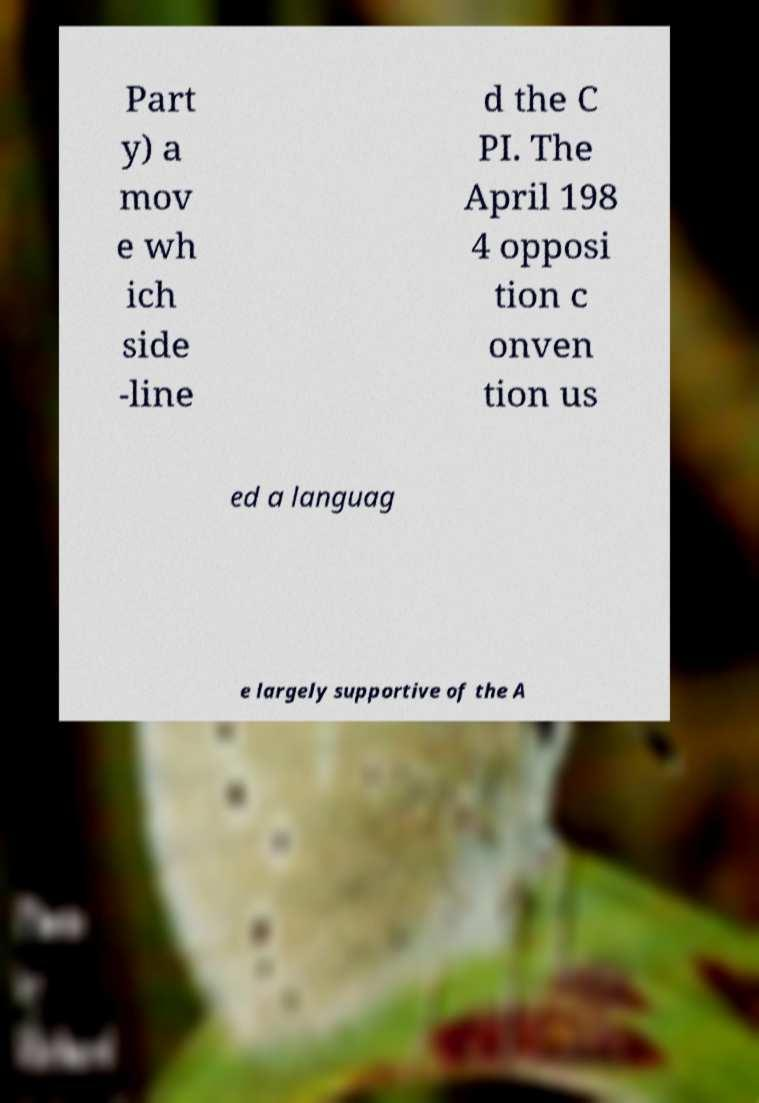There's text embedded in this image that I need extracted. Can you transcribe it verbatim? Part y) a mov e wh ich side -line d the C PI. The April 198 4 opposi tion c onven tion us ed a languag e largely supportive of the A 